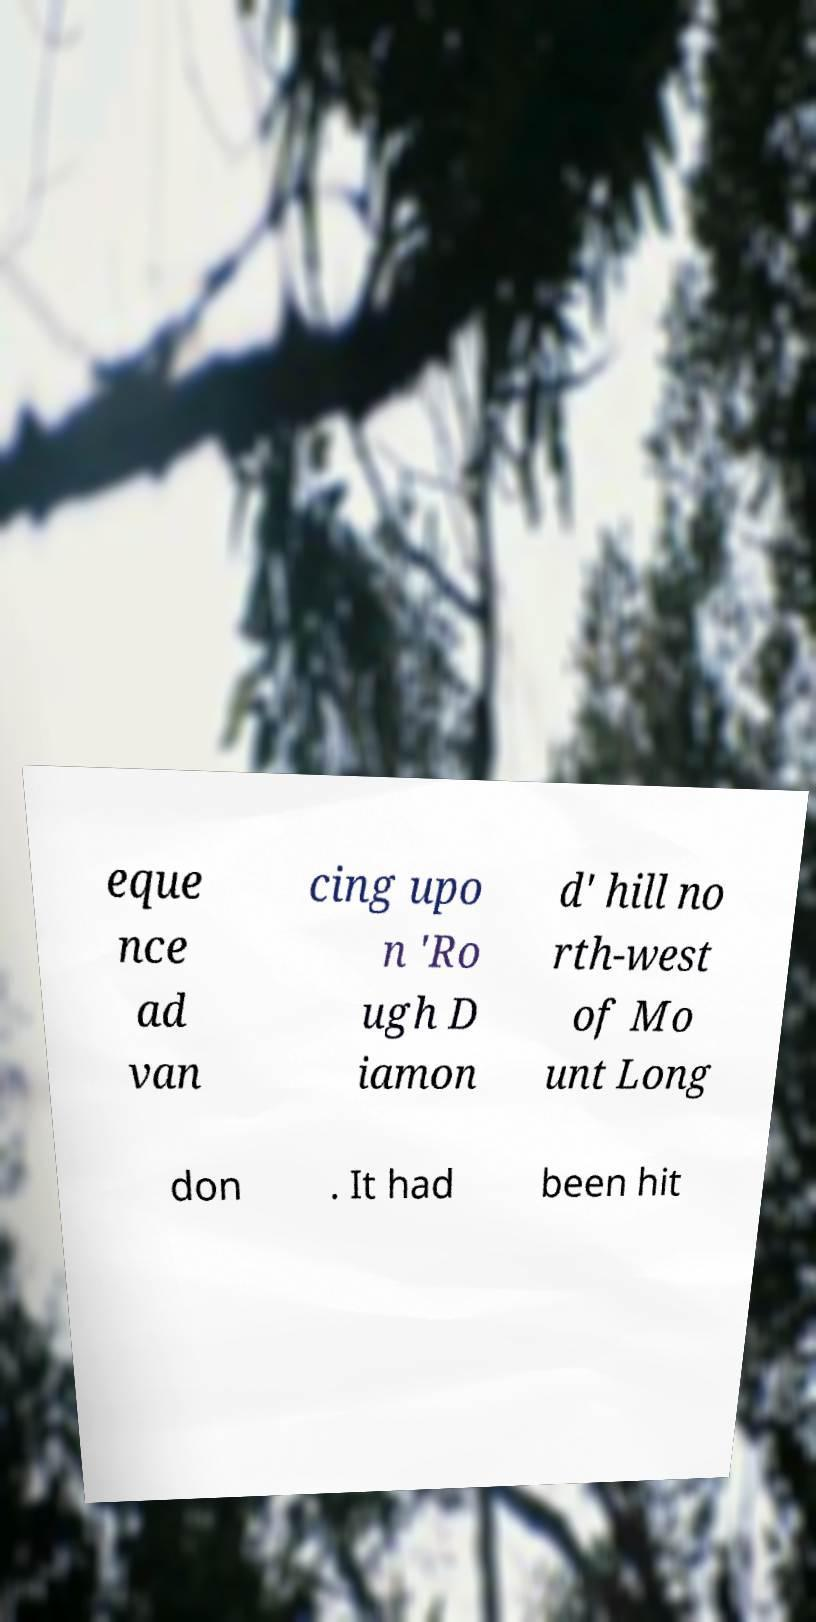Could you assist in decoding the text presented in this image and type it out clearly? eque nce ad van cing upo n 'Ro ugh D iamon d' hill no rth-west of Mo unt Long don . It had been hit 